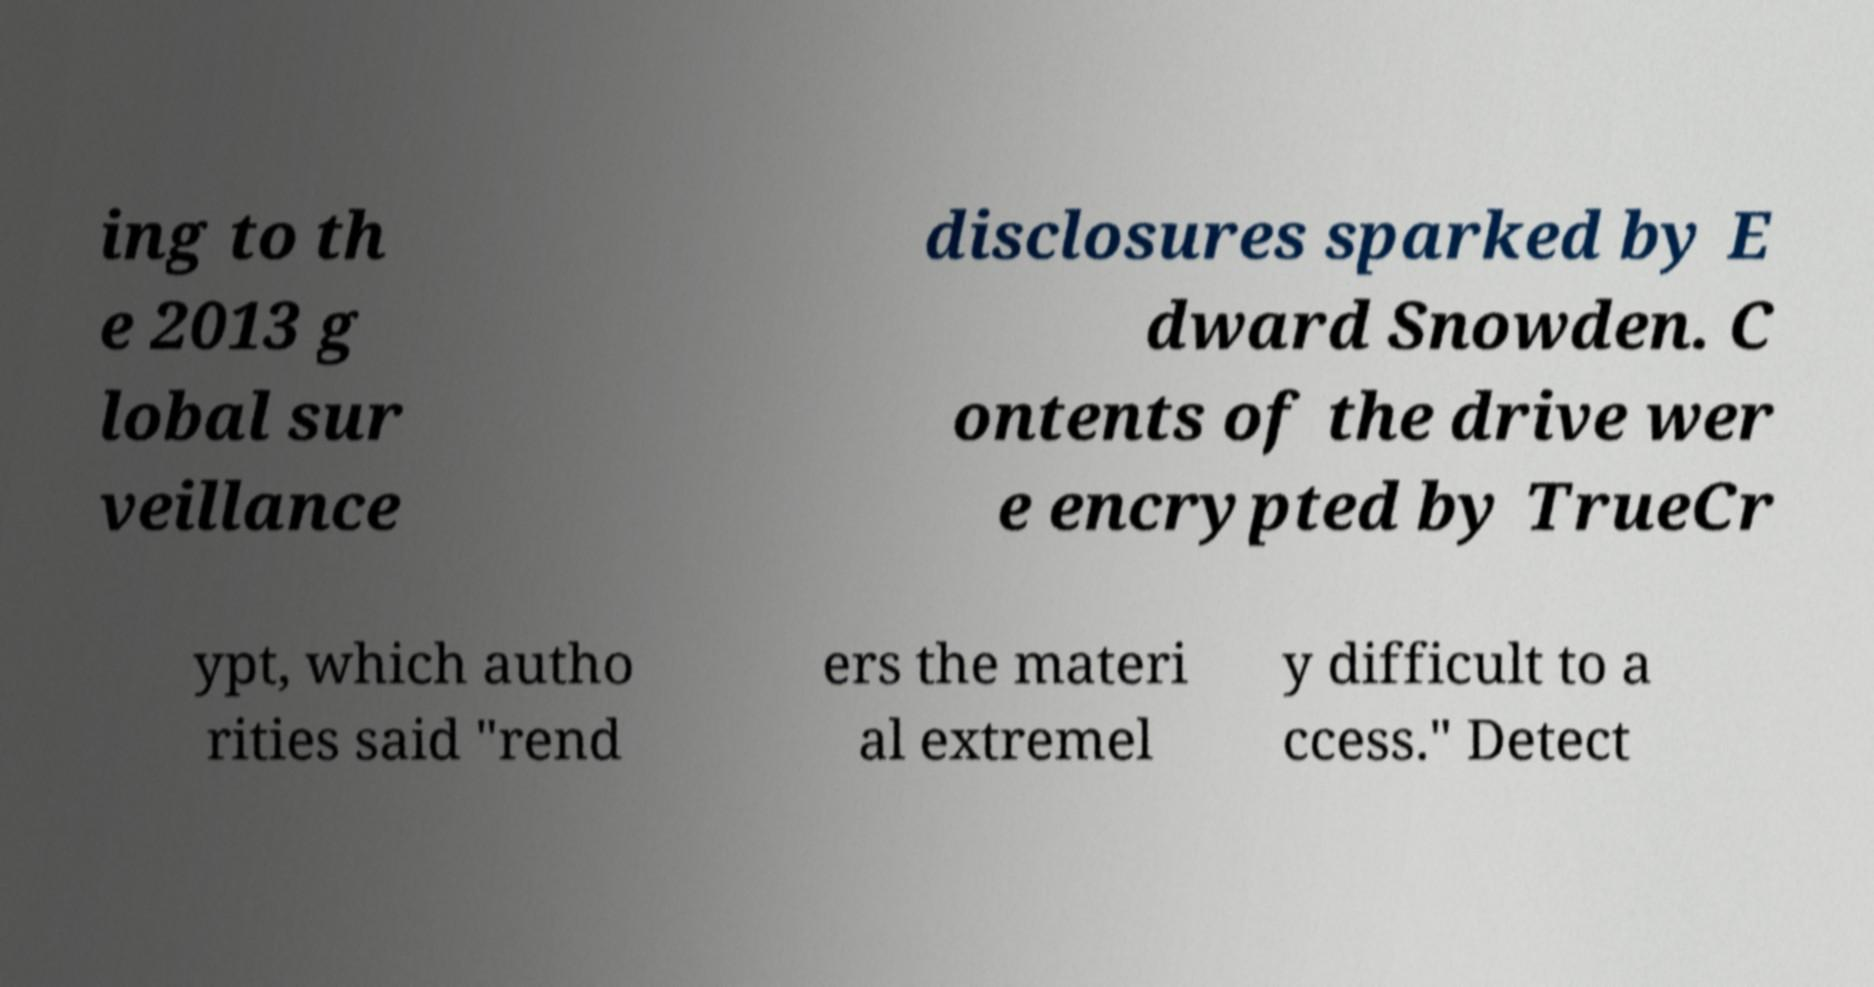Please identify and transcribe the text found in this image. ing to th e 2013 g lobal sur veillance disclosures sparked by E dward Snowden. C ontents of the drive wer e encrypted by TrueCr ypt, which autho rities said "rend ers the materi al extremel y difficult to a ccess." Detect 